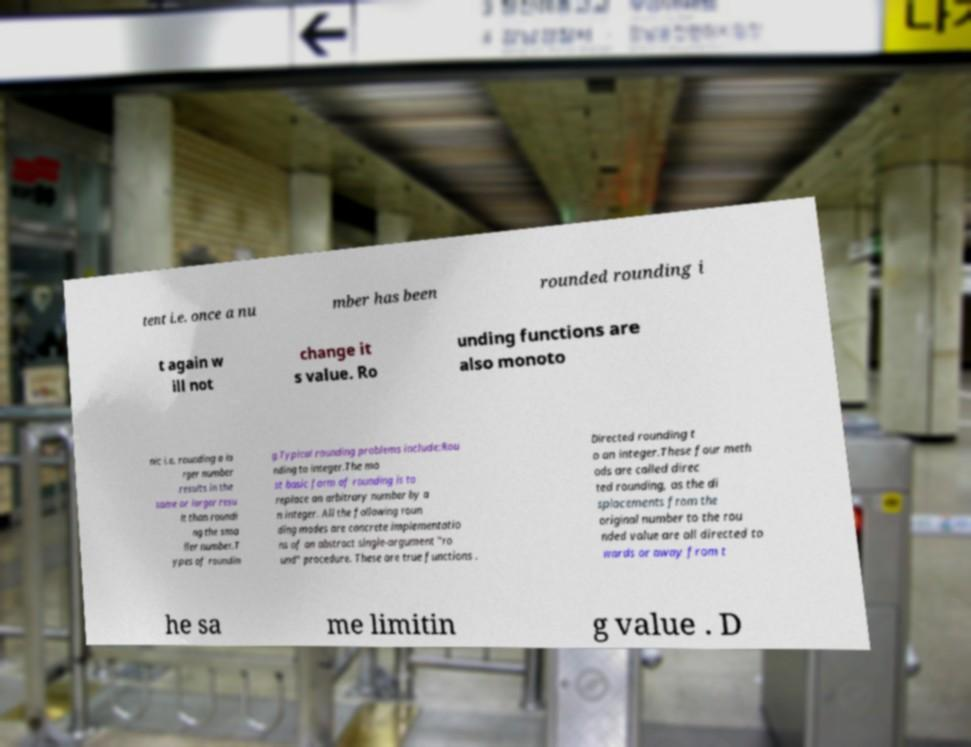Can you accurately transcribe the text from the provided image for me? tent i.e. once a nu mber has been rounded rounding i t again w ill not change it s value. Ro unding functions are also monoto nic i.e. rounding a la rger number results in the same or larger resu lt than roundi ng the sma ller number.T ypes of roundin g.Typical rounding problems include:Rou nding to integer.The mo st basic form of rounding is to replace an arbitrary number by a n integer. All the following roun ding modes are concrete implementatio ns of an abstract single-argument "ro und" procedure. These are true functions . Directed rounding t o an integer.These four meth ods are called direc ted rounding, as the di splacements from the original number to the rou nded value are all directed to wards or away from t he sa me limitin g value . D 